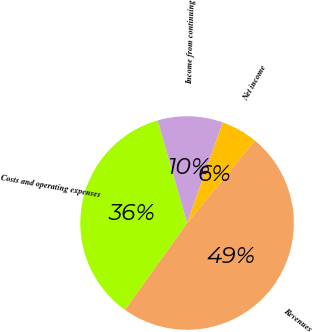Convert chart. <chart><loc_0><loc_0><loc_500><loc_500><pie_chart><fcel>Revenues<fcel>Costs and operating expenses<fcel>Income from continuing<fcel>Net income<nl><fcel>48.95%<fcel>35.66%<fcel>9.86%<fcel>5.52%<nl></chart> 